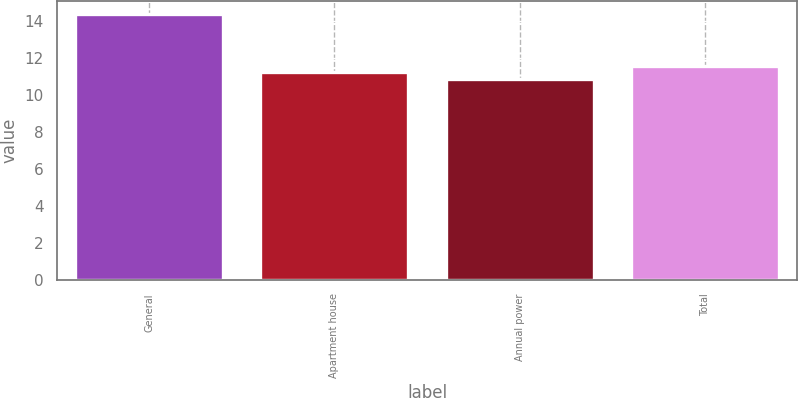Convert chart. <chart><loc_0><loc_0><loc_500><loc_500><bar_chart><fcel>General<fcel>Apartment house<fcel>Annual power<fcel>Total<nl><fcel>14.4<fcel>11.25<fcel>10.9<fcel>11.6<nl></chart> 